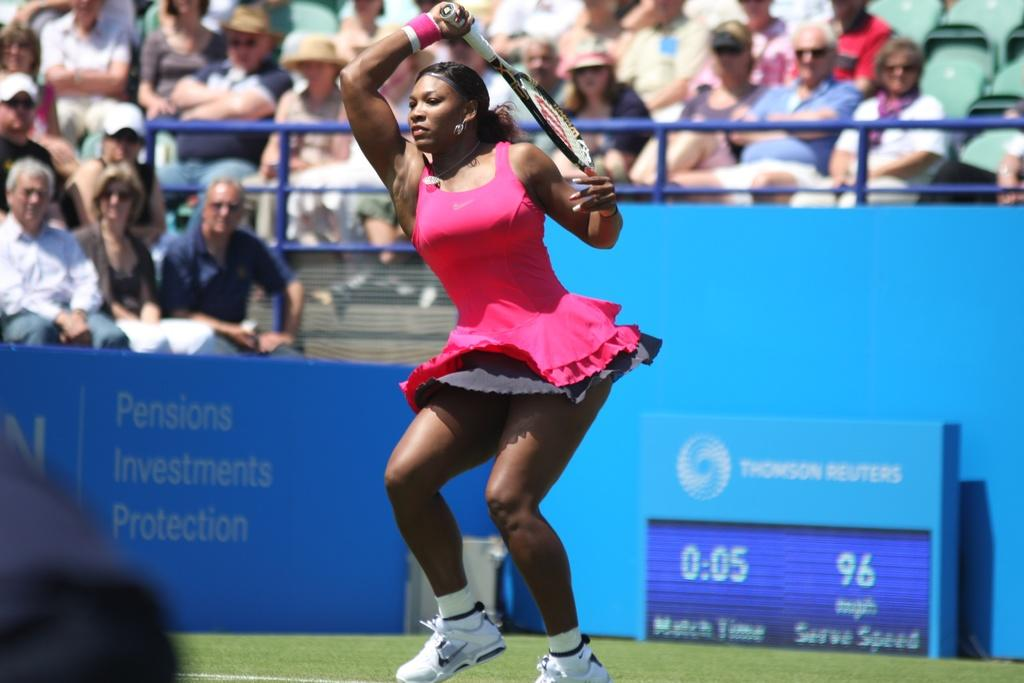Who is present in the image? There is a woman in the image. What is the woman holding in her hand? The woman is holding a racket with her hand. What can be seen in the background of the image? There is a hoarding, a screen, railing, and a group of people in the background of the image. What type of wine is being served at the aftermath of the event in the image? There is no event or wine present in the image; it features a woman holding a racket and various elements in the background. 